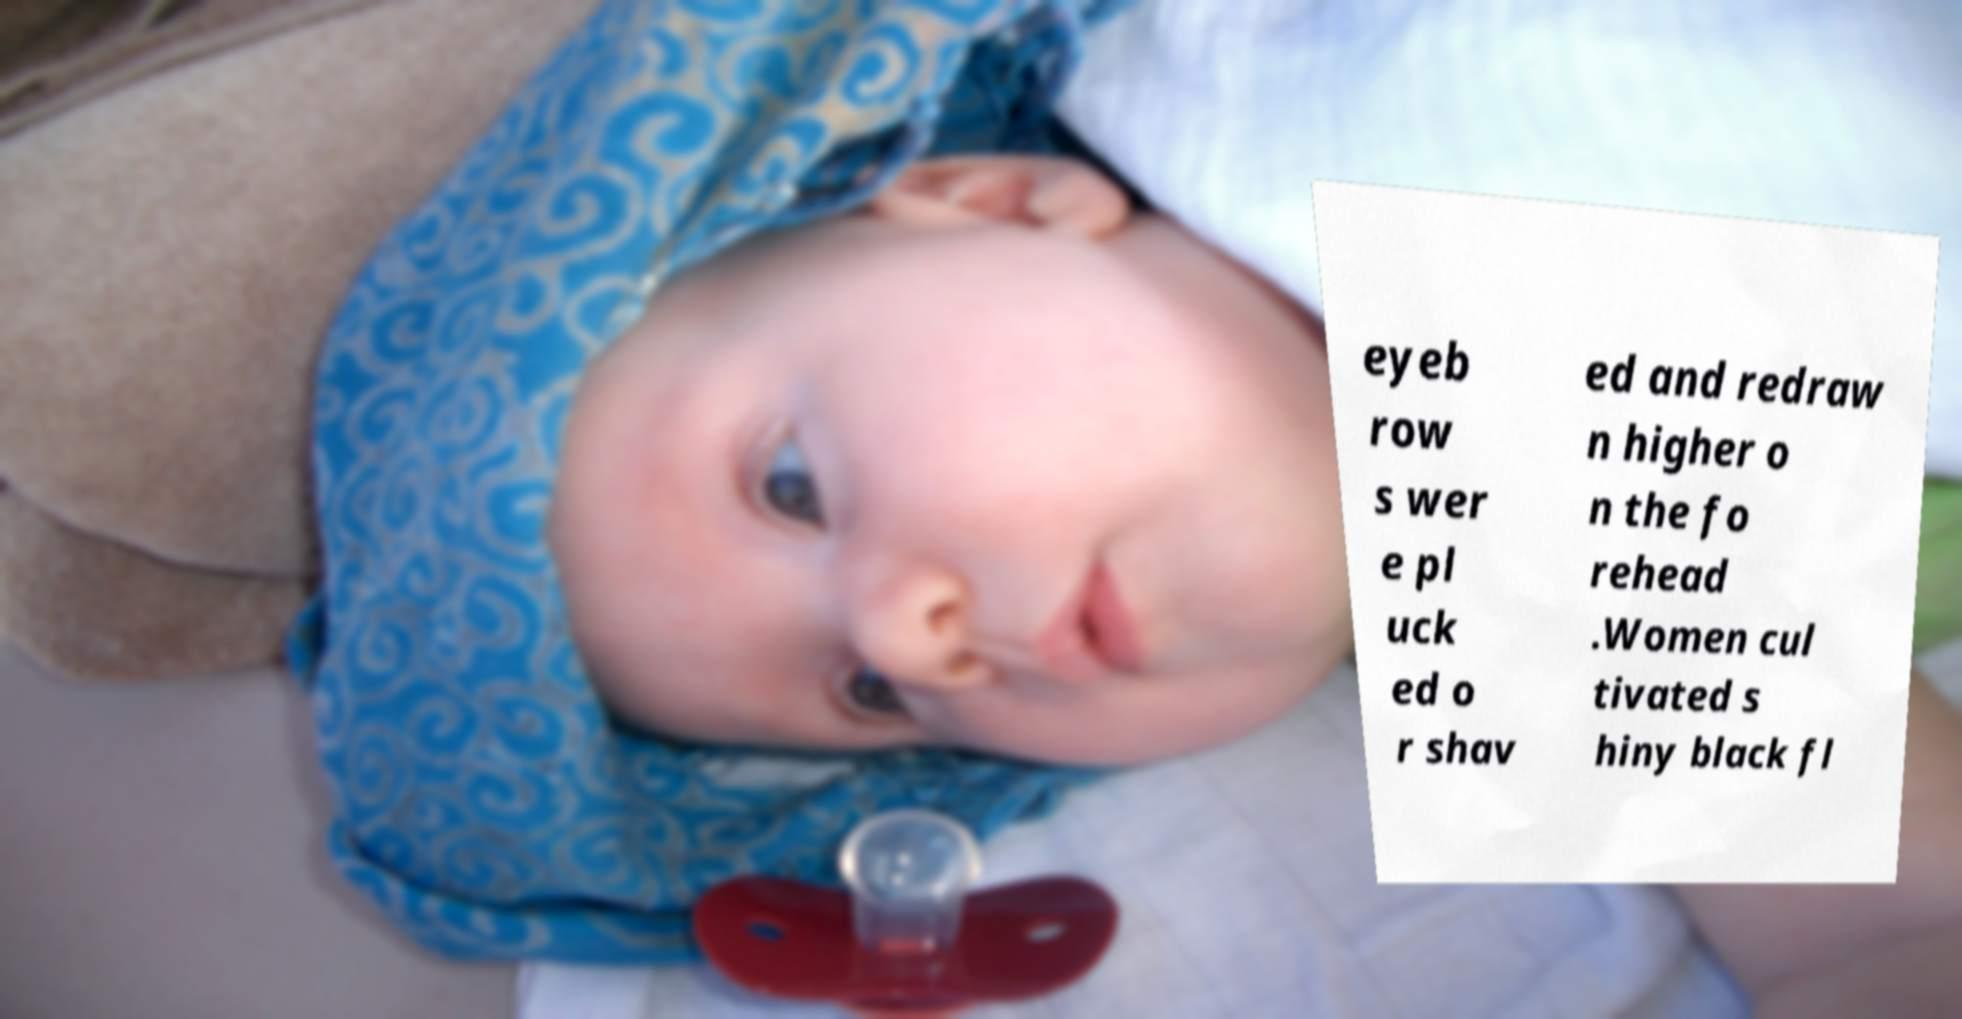Please identify and transcribe the text found in this image. eyeb row s wer e pl uck ed o r shav ed and redraw n higher o n the fo rehead .Women cul tivated s hiny black fl 